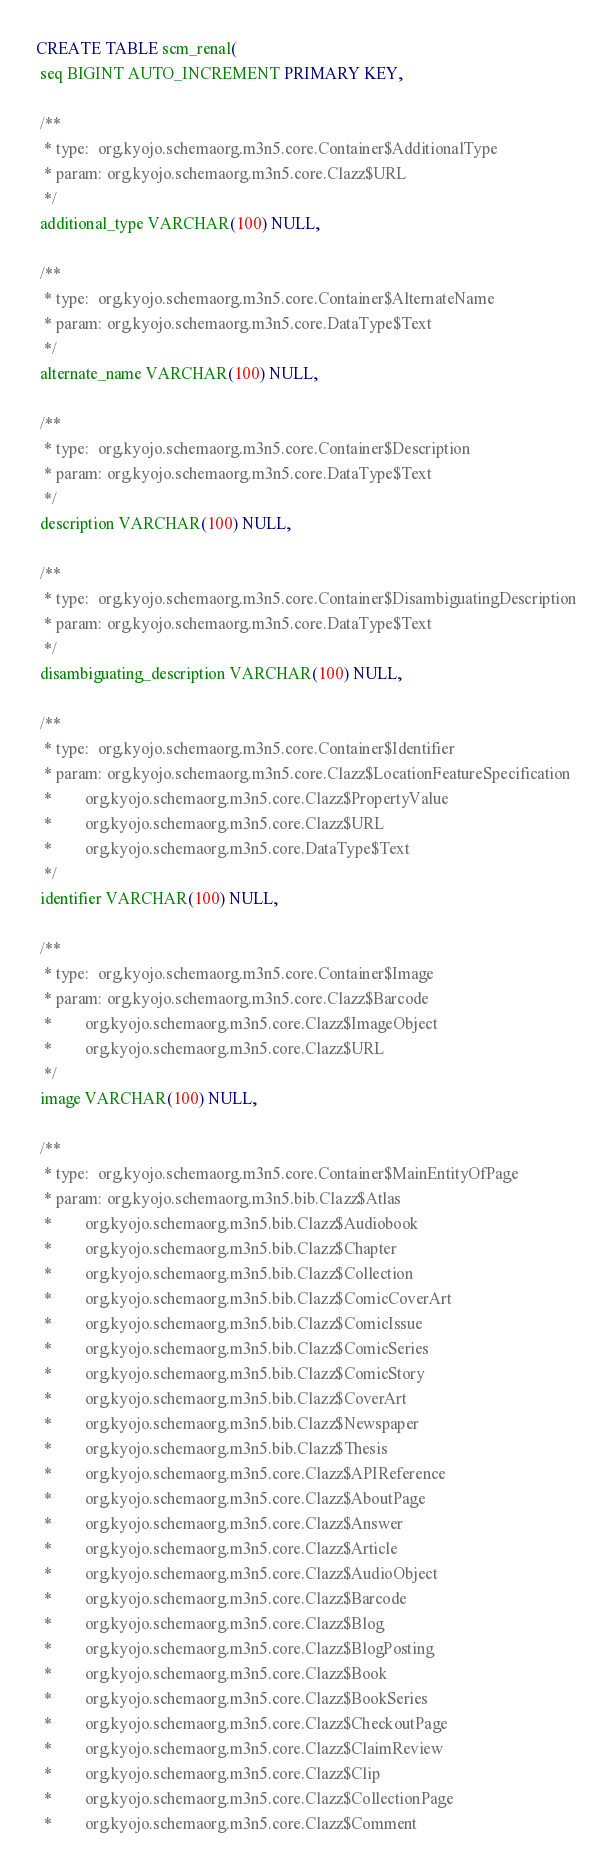Convert code to text. <code><loc_0><loc_0><loc_500><loc_500><_SQL_>CREATE TABLE scm_renal(
 seq BIGINT AUTO_INCREMENT PRIMARY KEY,

 /**
  * type:  org.kyojo.schemaorg.m3n5.core.Container$AdditionalType
  * param: org.kyojo.schemaorg.m3n5.core.Clazz$URL
  */
 additional_type VARCHAR(100) NULL,

 /**
  * type:  org.kyojo.schemaorg.m3n5.core.Container$AlternateName
  * param: org.kyojo.schemaorg.m3n5.core.DataType$Text
  */
 alternate_name VARCHAR(100) NULL,

 /**
  * type:  org.kyojo.schemaorg.m3n5.core.Container$Description
  * param: org.kyojo.schemaorg.m3n5.core.DataType$Text
  */
 description VARCHAR(100) NULL,

 /**
  * type:  org.kyojo.schemaorg.m3n5.core.Container$DisambiguatingDescription
  * param: org.kyojo.schemaorg.m3n5.core.DataType$Text
  */
 disambiguating_description VARCHAR(100) NULL,

 /**
  * type:  org.kyojo.schemaorg.m3n5.core.Container$Identifier
  * param: org.kyojo.schemaorg.m3n5.core.Clazz$LocationFeatureSpecification
  *        org.kyojo.schemaorg.m3n5.core.Clazz$PropertyValue
  *        org.kyojo.schemaorg.m3n5.core.Clazz$URL
  *        org.kyojo.schemaorg.m3n5.core.DataType$Text
  */
 identifier VARCHAR(100) NULL,

 /**
  * type:  org.kyojo.schemaorg.m3n5.core.Container$Image
  * param: org.kyojo.schemaorg.m3n5.core.Clazz$Barcode
  *        org.kyojo.schemaorg.m3n5.core.Clazz$ImageObject
  *        org.kyojo.schemaorg.m3n5.core.Clazz$URL
  */
 image VARCHAR(100) NULL,

 /**
  * type:  org.kyojo.schemaorg.m3n5.core.Container$MainEntityOfPage
  * param: org.kyojo.schemaorg.m3n5.bib.Clazz$Atlas
  *        org.kyojo.schemaorg.m3n5.bib.Clazz$Audiobook
  *        org.kyojo.schemaorg.m3n5.bib.Clazz$Chapter
  *        org.kyojo.schemaorg.m3n5.bib.Clazz$Collection
  *        org.kyojo.schemaorg.m3n5.bib.Clazz$ComicCoverArt
  *        org.kyojo.schemaorg.m3n5.bib.Clazz$ComicIssue
  *        org.kyojo.schemaorg.m3n5.bib.Clazz$ComicSeries
  *        org.kyojo.schemaorg.m3n5.bib.Clazz$ComicStory
  *        org.kyojo.schemaorg.m3n5.bib.Clazz$CoverArt
  *        org.kyojo.schemaorg.m3n5.bib.Clazz$Newspaper
  *        org.kyojo.schemaorg.m3n5.bib.Clazz$Thesis
  *        org.kyojo.schemaorg.m3n5.core.Clazz$APIReference
  *        org.kyojo.schemaorg.m3n5.core.Clazz$AboutPage
  *        org.kyojo.schemaorg.m3n5.core.Clazz$Answer
  *        org.kyojo.schemaorg.m3n5.core.Clazz$Article
  *        org.kyojo.schemaorg.m3n5.core.Clazz$AudioObject
  *        org.kyojo.schemaorg.m3n5.core.Clazz$Barcode
  *        org.kyojo.schemaorg.m3n5.core.Clazz$Blog
  *        org.kyojo.schemaorg.m3n5.core.Clazz$BlogPosting
  *        org.kyojo.schemaorg.m3n5.core.Clazz$Book
  *        org.kyojo.schemaorg.m3n5.core.Clazz$BookSeries
  *        org.kyojo.schemaorg.m3n5.core.Clazz$CheckoutPage
  *        org.kyojo.schemaorg.m3n5.core.Clazz$ClaimReview
  *        org.kyojo.schemaorg.m3n5.core.Clazz$Clip
  *        org.kyojo.schemaorg.m3n5.core.Clazz$CollectionPage
  *        org.kyojo.schemaorg.m3n5.core.Clazz$Comment</code> 